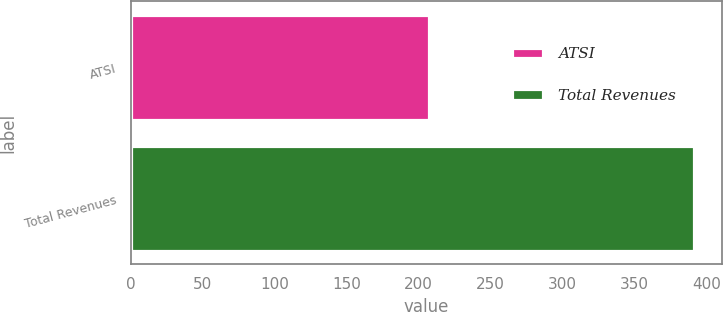<chart> <loc_0><loc_0><loc_500><loc_500><bar_chart><fcel>ATSI<fcel>Total Revenues<nl><fcel>207<fcel>391<nl></chart> 